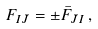<formula> <loc_0><loc_0><loc_500><loc_500>F _ { I \bar { J } } = \pm \bar { F } _ { \bar { J } I } \, ,</formula> 